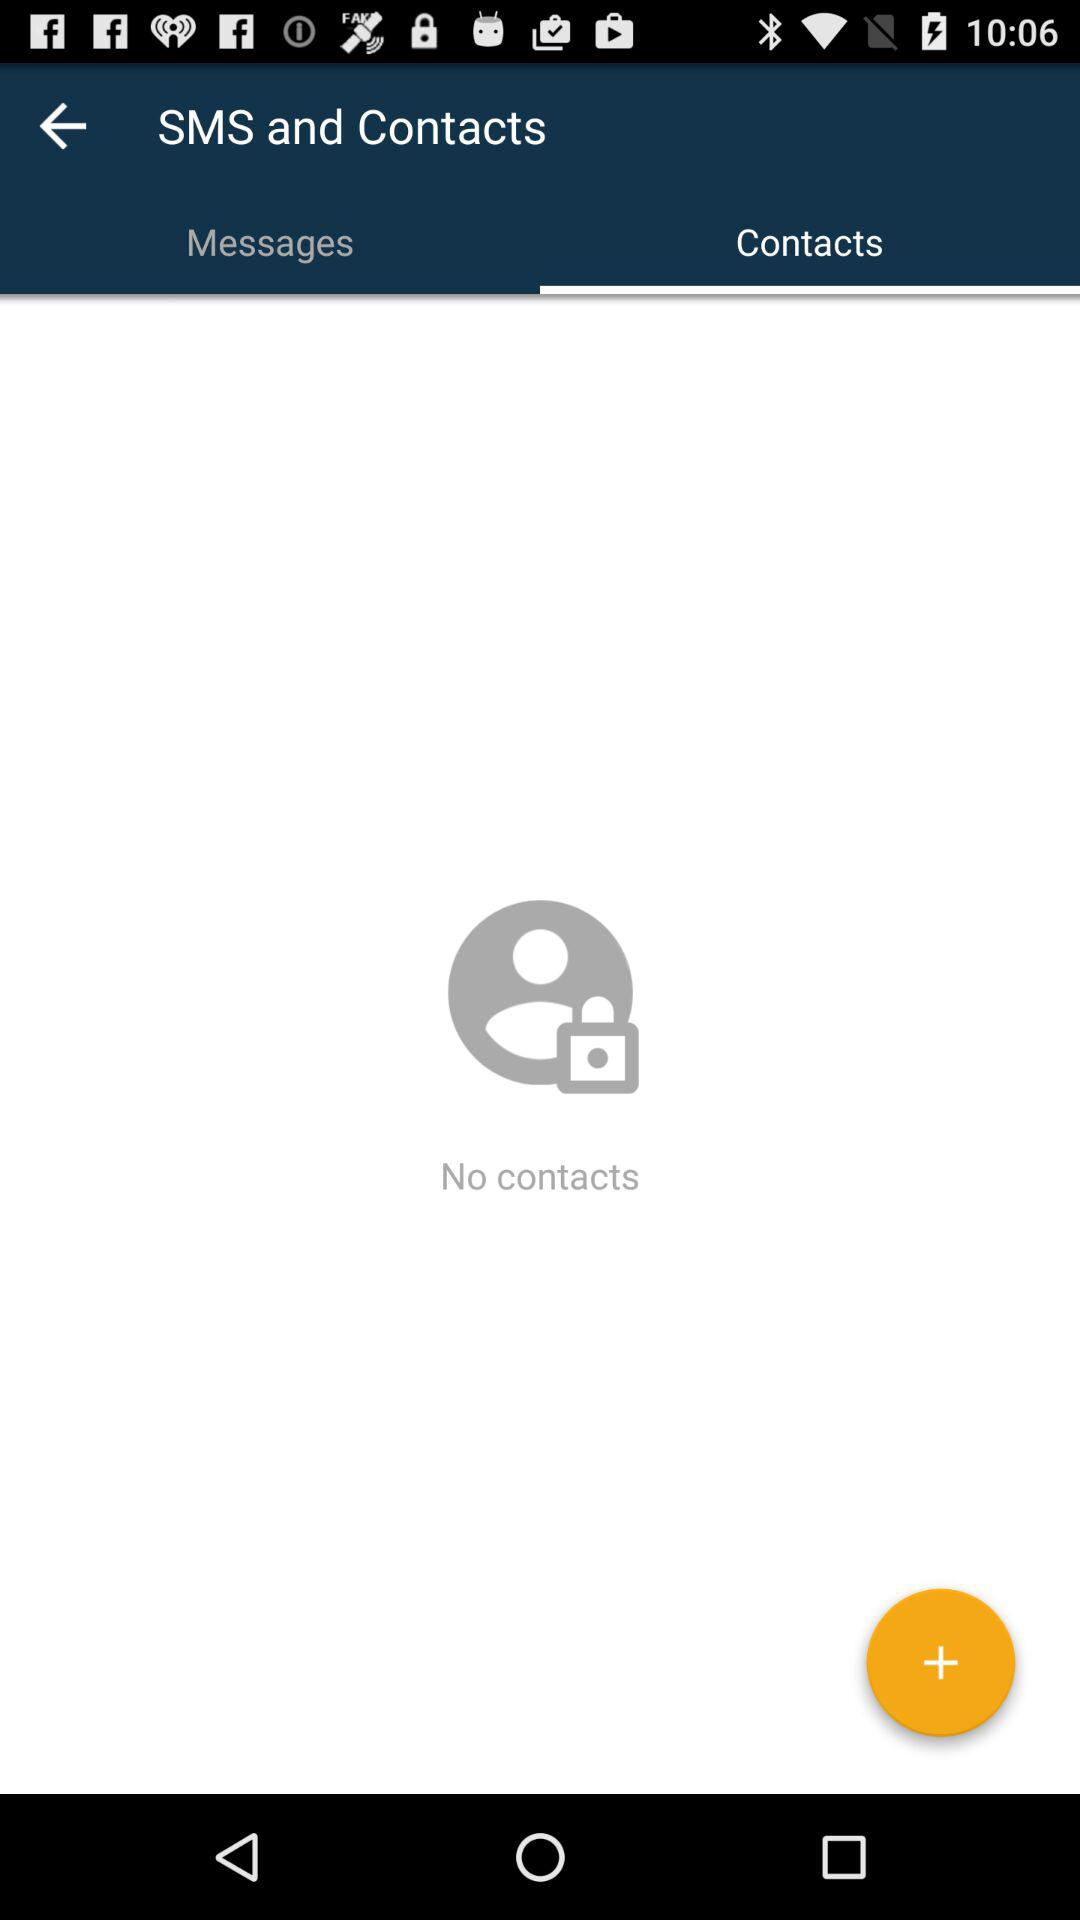Are there any contacts? There are no contacts. 